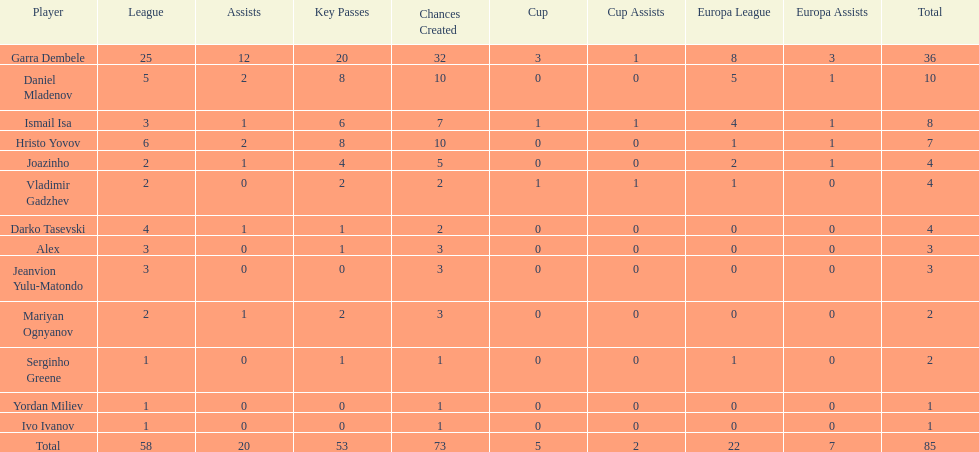Which sportsman belongs to the same class as joazinho and vladimir gadzhev? Mariyan Ognyanov. 